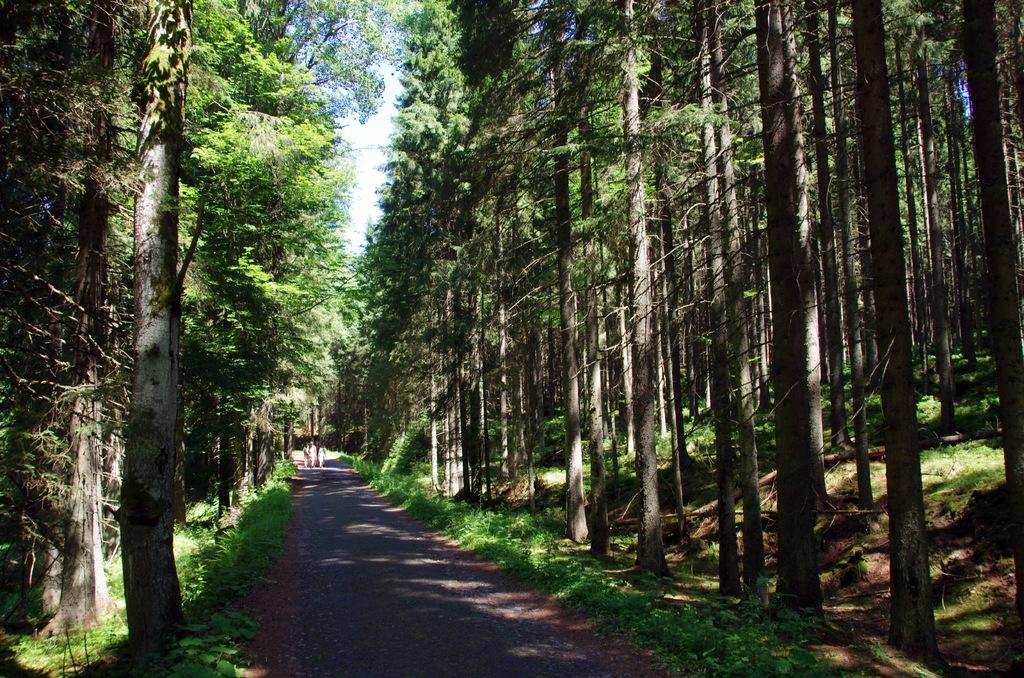What are the people in the image doing? The people in the image are walking on the road. What can be seen beside the road in the image? There are trees beside the road in the image. What type of wire is being used by the people walking on the road in the image? There is no wire present in the image; the people are simply walking on the road. 